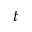Convert formula to latex. <formula><loc_0><loc_0><loc_500><loc_500>t</formula> 